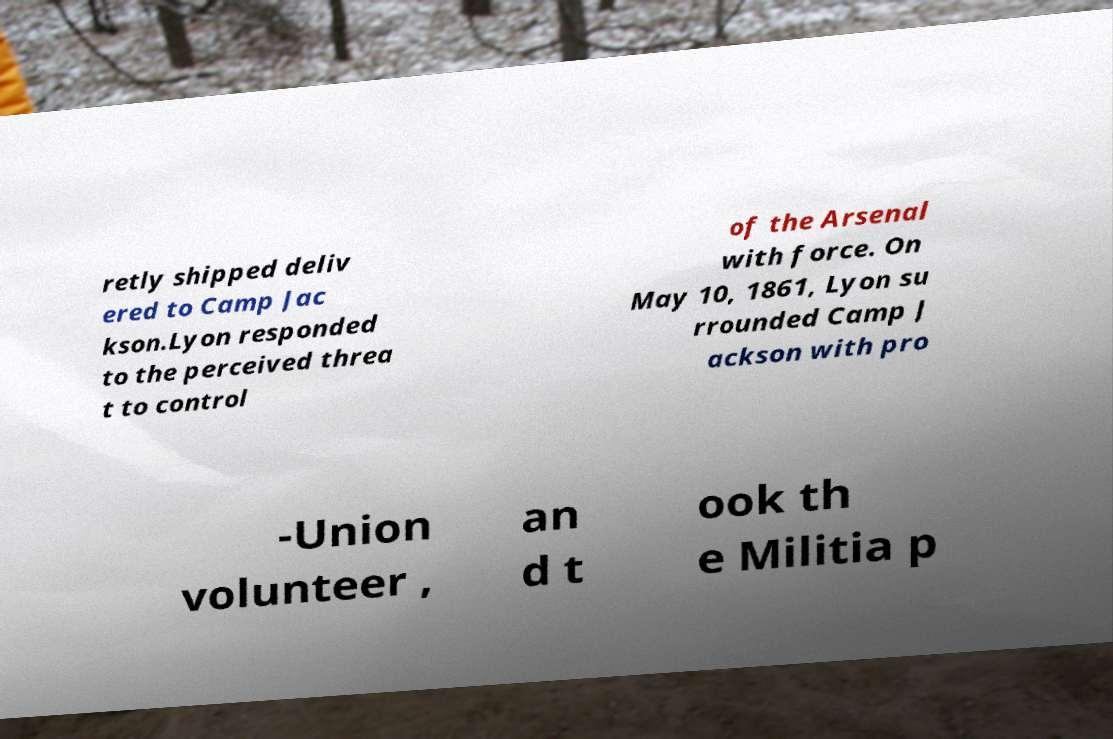Please read and relay the text visible in this image. What does it say? retly shipped deliv ered to Camp Jac kson.Lyon responded to the perceived threa t to control of the Arsenal with force. On May 10, 1861, Lyon su rrounded Camp J ackson with pro -Union volunteer , an d t ook th e Militia p 